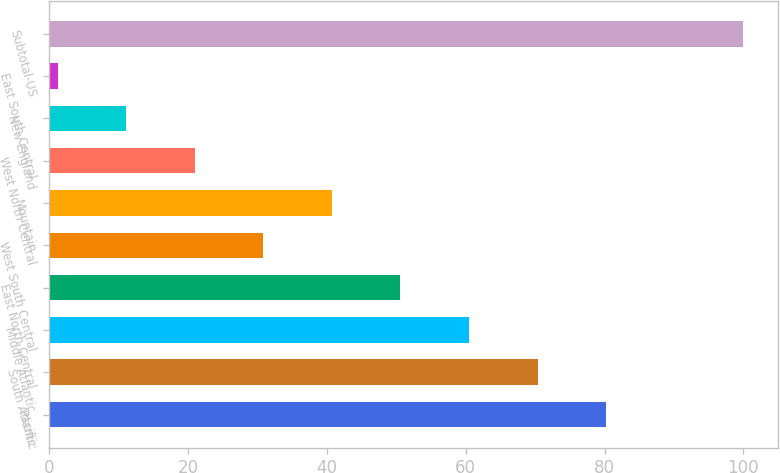<chart> <loc_0><loc_0><loc_500><loc_500><bar_chart><fcel>Pacific<fcel>South Atlantic<fcel>Middle Atlantic<fcel>East North Central<fcel>West South Central<fcel>Mountain<fcel>West North Central<fcel>New England<fcel>East South Central<fcel>Subtotal-US<nl><fcel>80.24<fcel>70.36<fcel>60.48<fcel>50.6<fcel>30.84<fcel>40.72<fcel>20.96<fcel>11.08<fcel>1.2<fcel>100<nl></chart> 